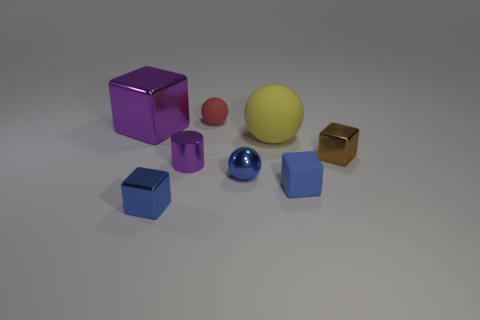What is the shape of the blue rubber object that is the same size as the purple metal cylinder?
Make the answer very short. Cube. How many big cubes have the same color as the small shiny cylinder?
Offer a terse response. 1. Are there fewer brown metallic objects in front of the purple cylinder than large yellow matte balls behind the blue shiny ball?
Provide a succinct answer. Yes. There is a tiny purple object; are there any metallic cubes in front of it?
Your answer should be very brief. Yes. There is a metal block that is on the right side of the small matte object behind the small brown metallic object; is there a blue rubber cube behind it?
Keep it short and to the point. No. Is the shape of the tiny rubber object right of the red rubber ball the same as  the tiny purple metal object?
Keep it short and to the point. No. What color is the large sphere that is the same material as the tiny red thing?
Give a very brief answer. Yellow. What number of large red cubes are made of the same material as the brown block?
Provide a short and direct response. 0. There is a tiny matte object that is to the right of the tiny rubber object that is behind the purple metal object behind the brown block; what color is it?
Offer a very short reply. Blue. Do the blue ball and the blue matte object have the same size?
Your response must be concise. Yes. 